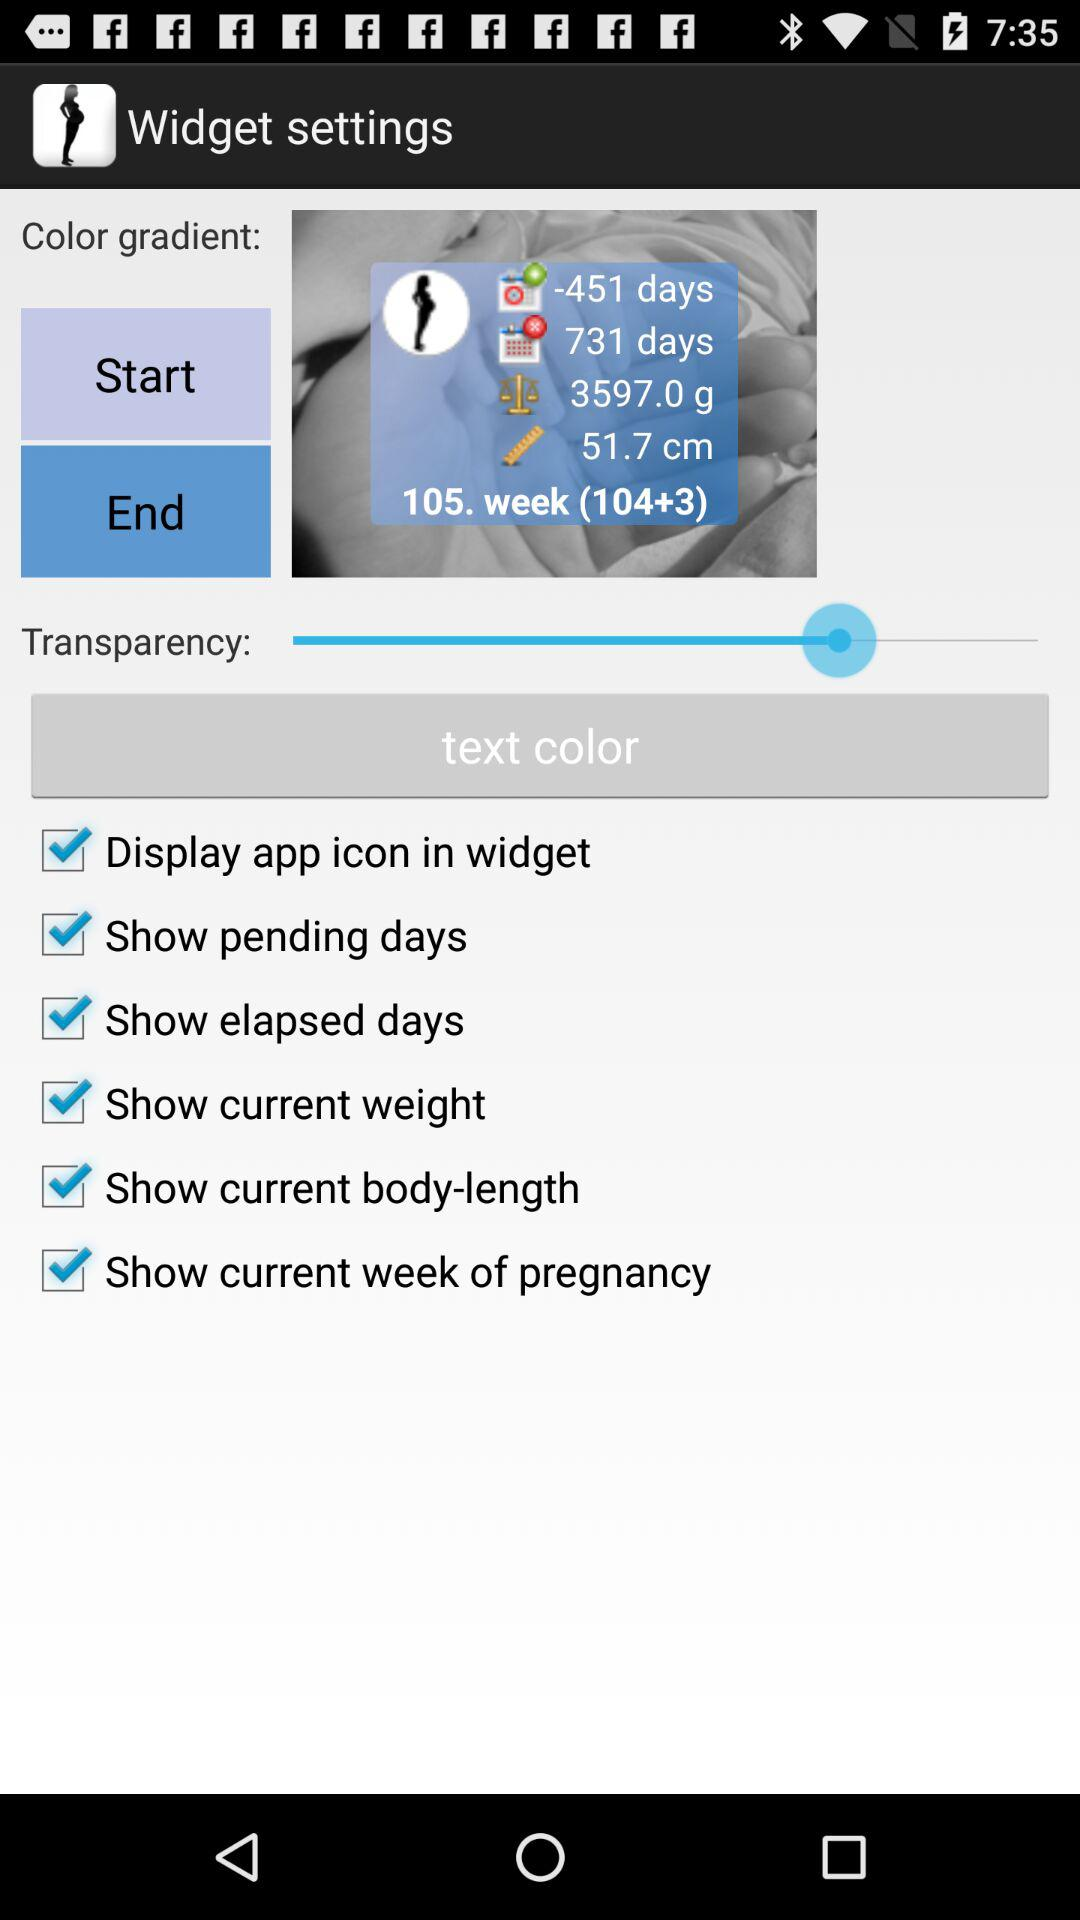How many weeks are there in widget? There are 105 weeks in the widget. 